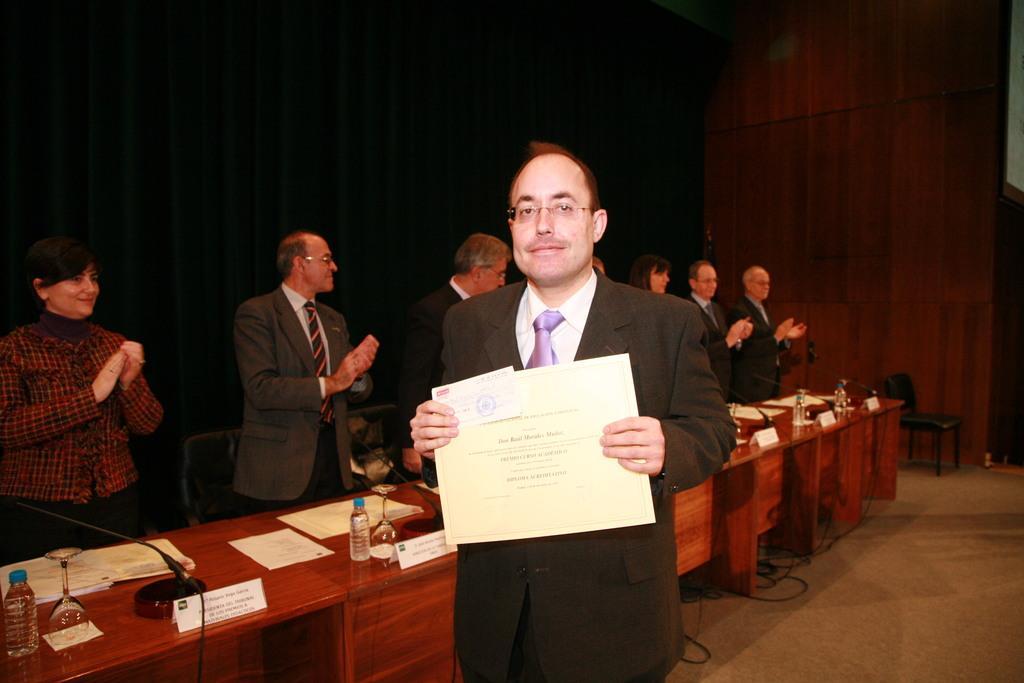Describe this image in one or two sentences. In the middle of the image a man is standing and smiling and holding some papers. Behind him there is a table, on the table there are some glasses and bottles and papers and microphones. Behind the table few people are standing. Behind them there is wall. Behind the table there is a chair. 